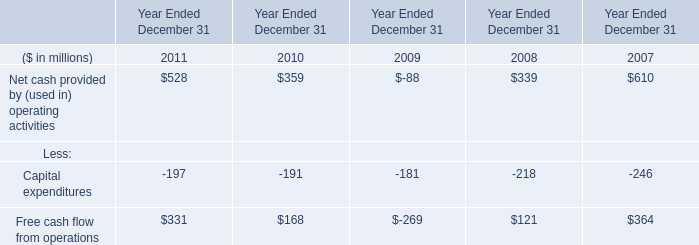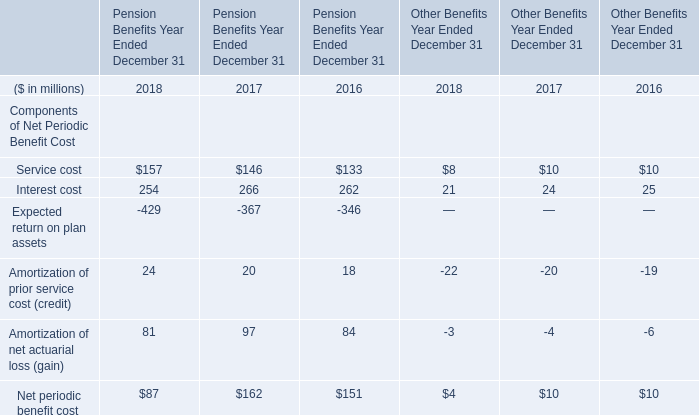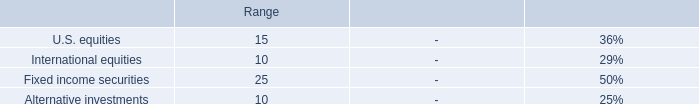Which element for Pension Benefits Year Ended December 31 exceeds 30 % of total in 2018? 
Answer: Service cost, Interest cost, Amortization of net actuarial loss (gain). 